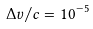Convert formula to latex. <formula><loc_0><loc_0><loc_500><loc_500>\Delta v / c = 1 0 ^ { - 5 }</formula> 